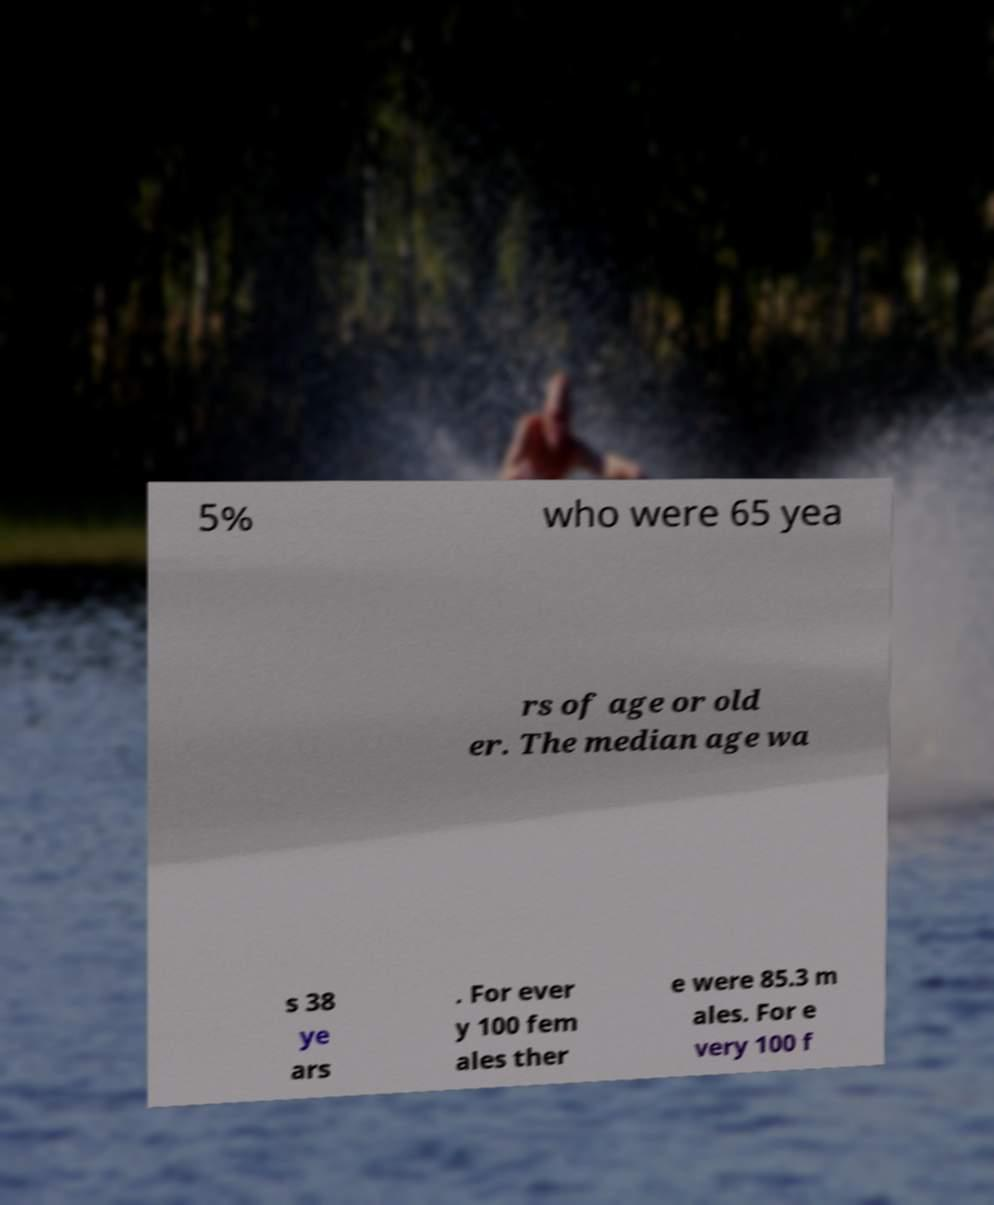Can you read and provide the text displayed in the image?This photo seems to have some interesting text. Can you extract and type it out for me? 5% who were 65 yea rs of age or old er. The median age wa s 38 ye ars . For ever y 100 fem ales ther e were 85.3 m ales. For e very 100 f 